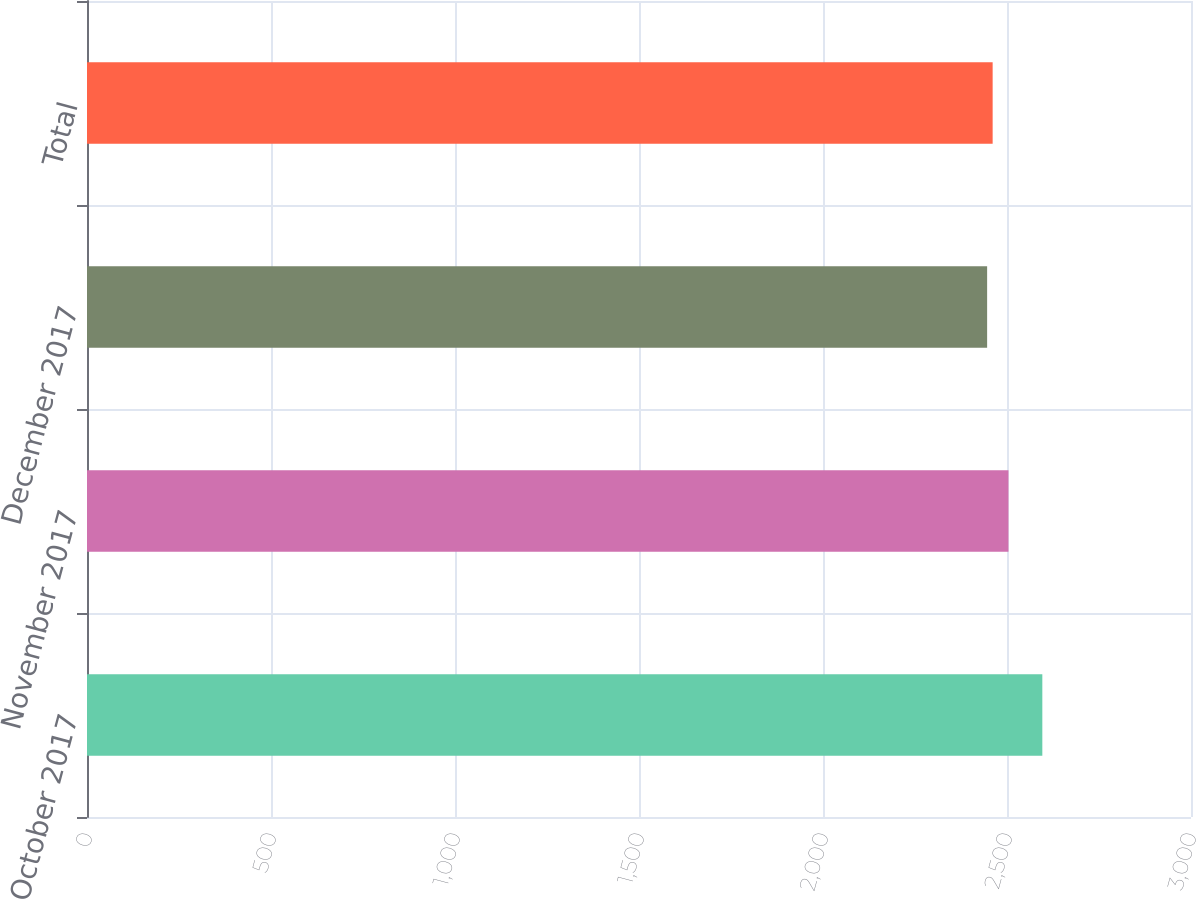<chart> <loc_0><loc_0><loc_500><loc_500><bar_chart><fcel>October 2017<fcel>November 2017<fcel>December 2017<fcel>Total<nl><fcel>2596<fcel>2504<fcel>2446<fcel>2461<nl></chart> 